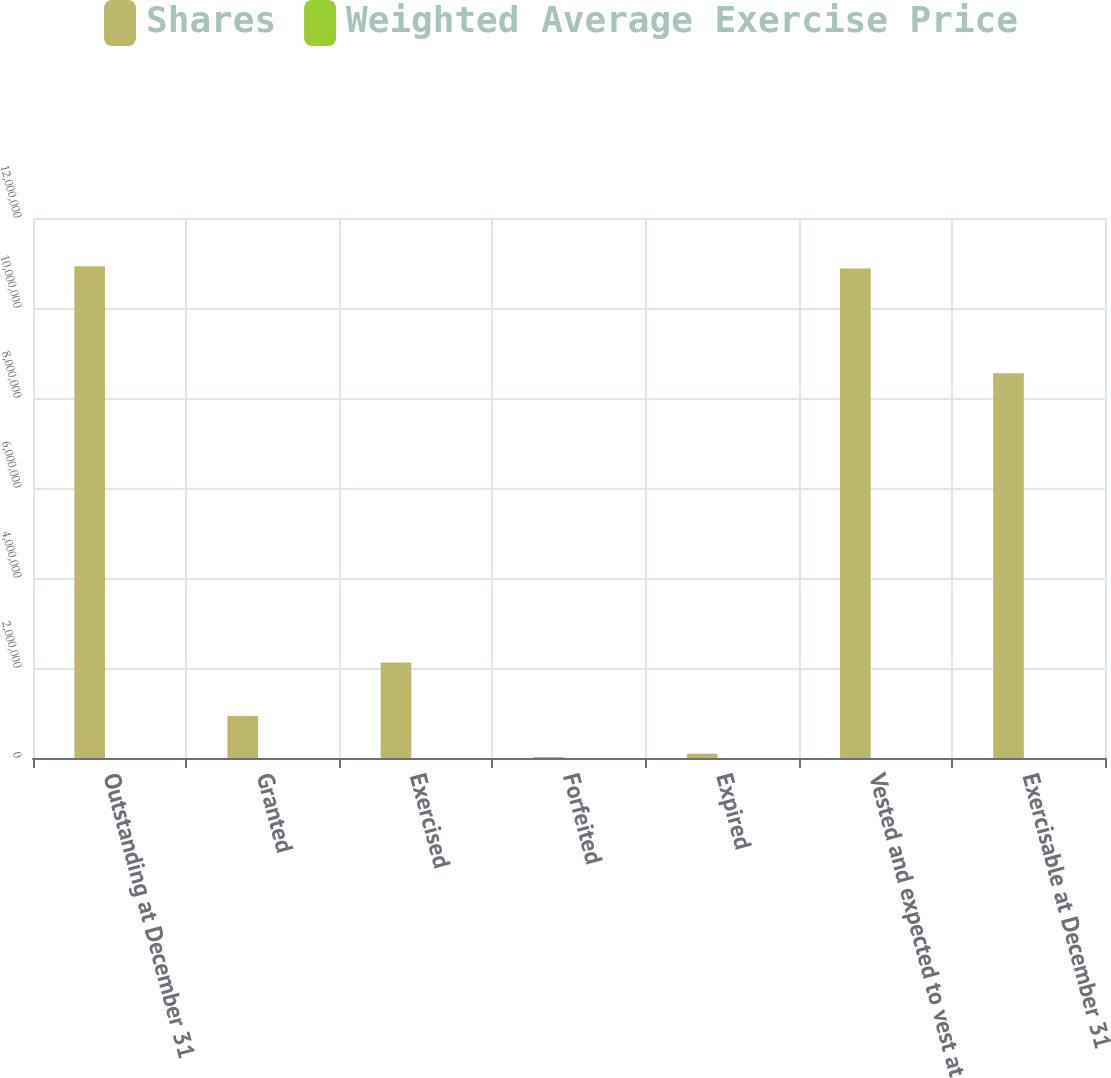Convert chart. <chart><loc_0><loc_0><loc_500><loc_500><stacked_bar_chart><ecel><fcel>Outstanding at December 31<fcel>Granted<fcel>Exercised<fcel>Forfeited<fcel>Expired<fcel>Vested and expected to vest at<fcel>Exercisable at December 31<nl><fcel>Shares<fcel>1.09261e+07<fcel>934939<fcel>2.12193e+06<fcel>22074<fcel>96290<fcel>1.08803e+07<fcel>8.54793e+06<nl><fcel>Weighted Average Exercise Price<fcel>66.18<fcel>78.1<fcel>62.95<fcel>68.94<fcel>87.33<fcel>66.13<fcel>64.96<nl></chart> 